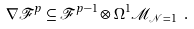<formula> <loc_0><loc_0><loc_500><loc_500>\nabla \mathcal { F } ^ { p } \subseteq \mathcal { F } ^ { p - 1 } \otimes \Omega ^ { 1 } \mathcal { M } _ { \mathcal { N } = 1 } \ .</formula> 